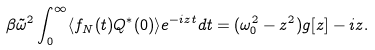<formula> <loc_0><loc_0><loc_500><loc_500>\beta \tilde { \omega } ^ { 2 } \int _ { 0 } ^ { \infty } \langle f _ { N } ( t ) Q ^ { * } ( 0 ) \rangle e ^ { - i z t } d t = ( \omega _ { 0 } ^ { 2 } - z ^ { 2 } ) g [ z ] - i z .</formula> 